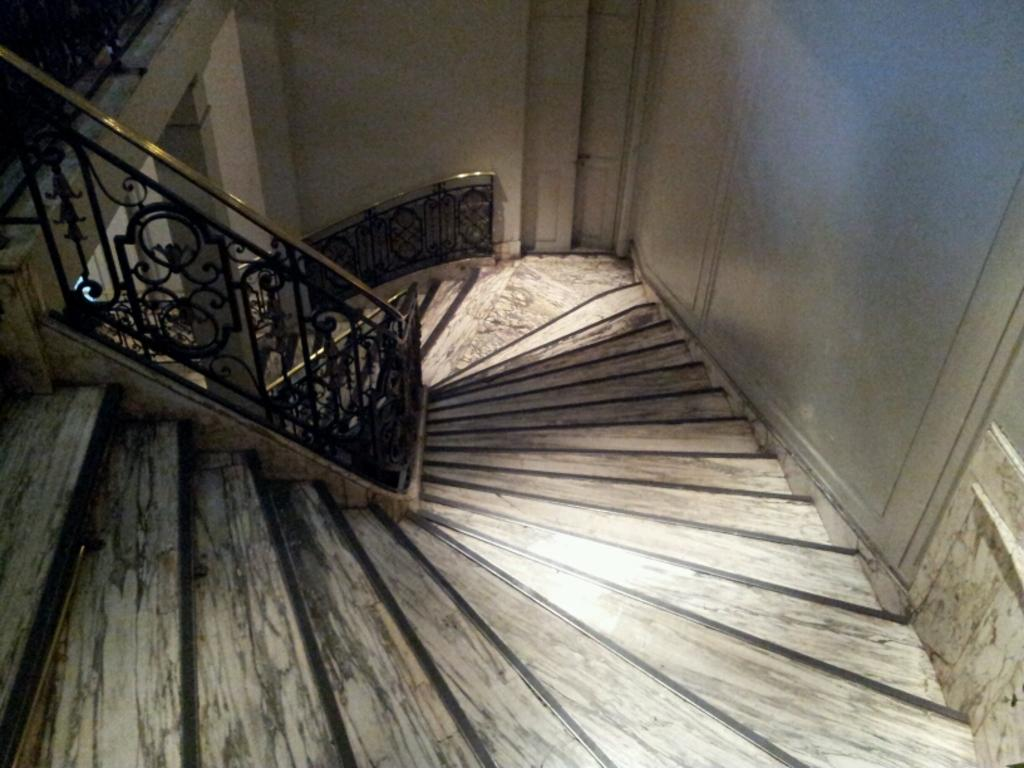What type of location is depicted in the image? The image is an inside view of a building. What architectural feature can be seen in the image? There are stairs in the image. What safety feature is present in the image? Railings are present in the image. What is visible on the right side of the image? There is a wall visible on the right side of the image. What action is the wall performing in the image? Walls do not perform actions; they are stationary structures. 